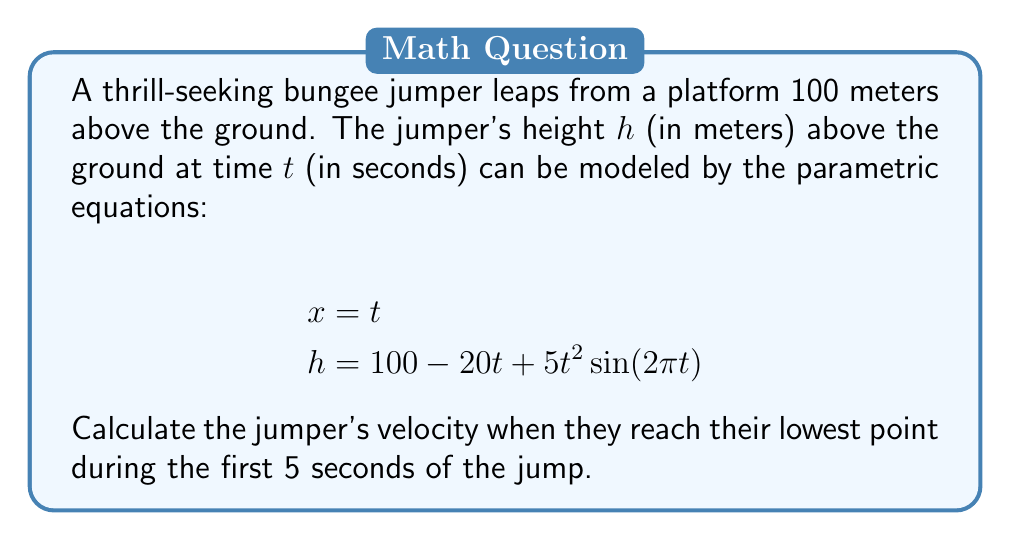Teach me how to tackle this problem. To solve this problem, we'll follow these steps:

1) First, we need to find the time t when the jumper reaches their lowest point within the first 5 seconds. This occurs when the derivative of h with respect to t is zero.

2) The derivative of h with respect to t is:

   $$\frac{dh}{dt} = -20 + 10t\sin(2\pi t) + 10\pi t^2 \cos(2\pi t)$$

3) We can't solve this analytically, so we'll use a graphing calculator or computer software to plot h(t) for 0 ≤ t ≤ 5 and find the minimum point.

4) The graph shows that the minimum occurs at approximately t = 2.25 seconds.

5) Now that we know the time of the lowest point, we can calculate the velocity at this point. The velocity is a vector with components (dx/dt, dh/dt).

6) We know that dx/dt = 1 (since x = t).

7) We can calculate dh/dt at t = 2.25:

   $$\frac{dh}{dt}\bigg|_{t=2.25} = -20 + 10(2.25)\sin(4.5\pi) + 10\pi(2.25)^2 \cos(4.5\pi)$$

8) Evaluating this:

   $$\frac{dh}{dt}\bigg|_{t=2.25} \approx 14.73$$

9) Therefore, the velocity vector at the lowest point is approximately (1, 14.73).

10) The magnitude of this velocity vector is:

    $$v = \sqrt{1^2 + 14.73^2} \approx 14.77 \text{ m/s}$$

This represents the jumper's speed at their lowest point.
Answer: The jumper's velocity at their lowest point during the first 5 seconds is approximately 14.77 m/s. 